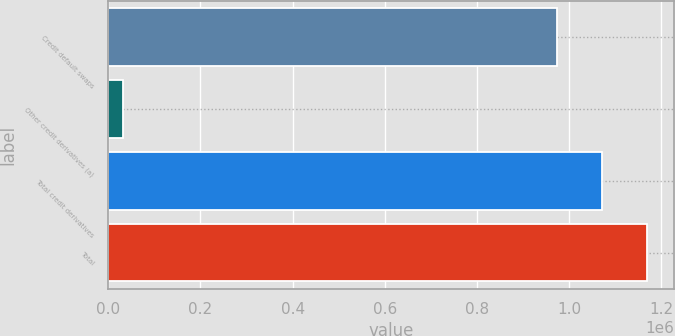Convert chart. <chart><loc_0><loc_0><loc_500><loc_500><bar_chart><fcel>Credit default swaps<fcel>Other credit derivatives (a)<fcel>Total credit derivatives<fcel>Total<nl><fcel>974252<fcel>31859<fcel>1.07168e+06<fcel>1.1691e+06<nl></chart> 